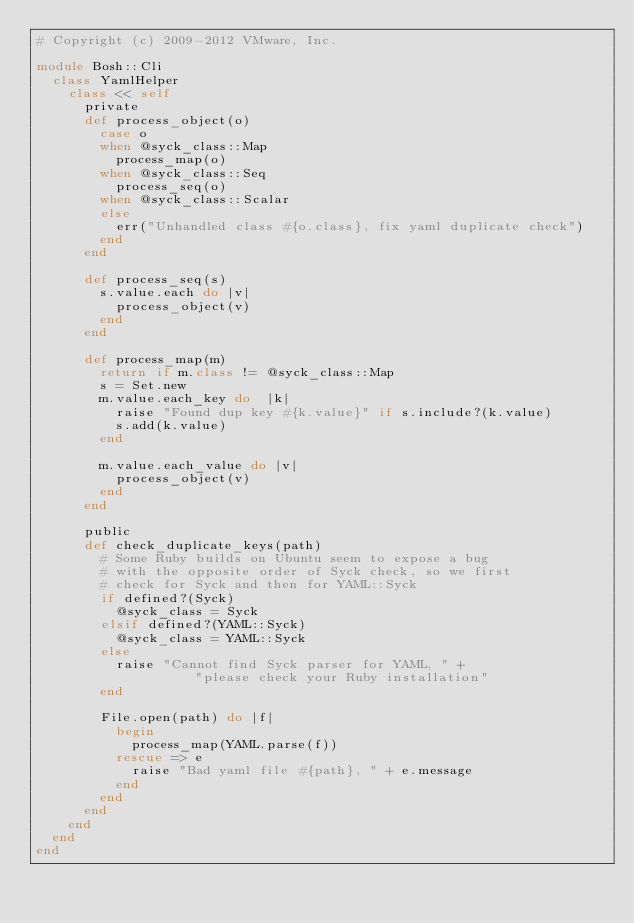Convert code to text. <code><loc_0><loc_0><loc_500><loc_500><_Ruby_># Copyright (c) 2009-2012 VMware, Inc.

module Bosh::Cli
  class YamlHelper
    class << self
      private
      def process_object(o)
        case o
        when @syck_class::Map
          process_map(o)
        when @syck_class::Seq
          process_seq(o)
        when @syck_class::Scalar
        else
          err("Unhandled class #{o.class}, fix yaml duplicate check")
        end
      end

      def process_seq(s)
        s.value.each do |v|
          process_object(v)
        end
      end

      def process_map(m)
        return if m.class != @syck_class::Map
        s = Set.new
        m.value.each_key do  |k|
          raise "Found dup key #{k.value}" if s.include?(k.value)
          s.add(k.value)
        end

        m.value.each_value do |v|
          process_object(v)
        end
      end

      public
      def check_duplicate_keys(path)
        # Some Ruby builds on Ubuntu seem to expose a bug
        # with the opposite order of Syck check, so we first
        # check for Syck and then for YAML::Syck
        if defined?(Syck)
          @syck_class = Syck
        elsif defined?(YAML::Syck)
          @syck_class = YAML::Syck
        else
          raise "Cannot find Syck parser for YAML, " +
                    "please check your Ruby installation"
        end

        File.open(path) do |f|
          begin
            process_map(YAML.parse(f))
          rescue => e
            raise "Bad yaml file #{path}, " + e.message
          end
        end
      end
    end
  end
end
</code> 